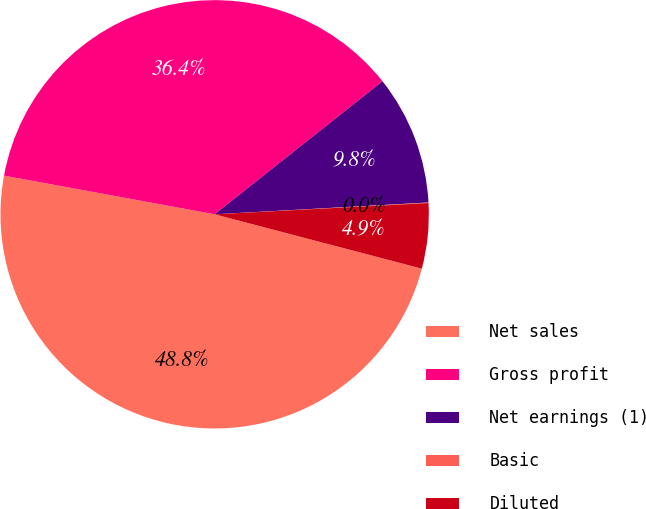<chart> <loc_0><loc_0><loc_500><loc_500><pie_chart><fcel>Net sales<fcel>Gross profit<fcel>Net earnings (1)<fcel>Basic<fcel>Diluted<nl><fcel>48.8%<fcel>36.44%<fcel>9.79%<fcel>0.04%<fcel>4.92%<nl></chart> 